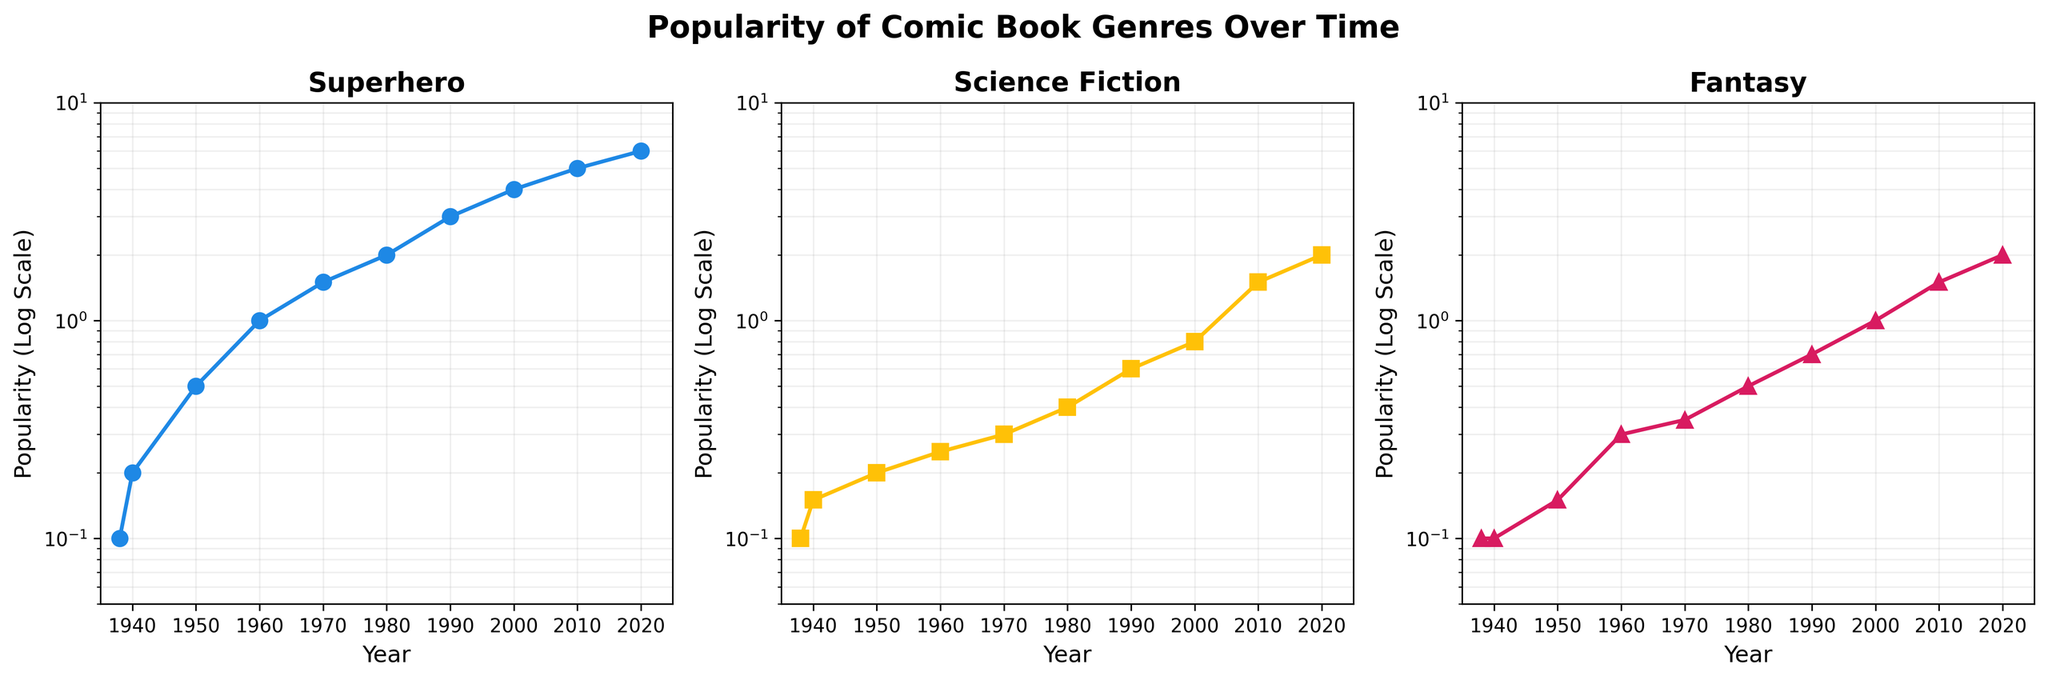How many unique years are represented in each subplot? There are ten unique data points in each subplot, as each genre (Superhero, Science Fiction, Fantasy) has popularity values displayed from 1938 to 2020.
Answer: 10 Which subplot shows the greatest increase in popularity from 1938 to 2020? To determine the greatest increase, we compare the change in popularity values from 1938 to 2020 for each genre. Superhero increased from 0.1 to 6, Science Fiction from 0.1 to 2, and Fantasy from 0.1 to 2. Therefore, the Superhero subplot shows the greatest increase.
Answer: Superhero By what factor did the popularity of Science Fiction change from 1970 to 1990? The popularity of Science Fiction in 1970 was 0.3 and in 1990 was 0.6. The factor change is calculated as 0.6 / 0.3 = 2.
Answer: 2 Between which years did Fantasy experience the most rapid growth? The most rapid growth can be observed between 1980 and 1990, where the popularity of Fantasy increased from 0.5 to 0.7, nearly doubling. By comparing the changes between other decade intervals, this period shows the steepest increase.
Answer: 1980 to 1990 What is the median popularity value for the Superhero genre? The median of the Superhero genre values in log scale can be found by ordering the values: 0.1, 0.2, 0.5, 1, 1.5, 2, 3, 4, 5, 6 and choosing the middle value(s). For 10 data points, the median is the average of the 5th and 6th values: (1.5 + 2) / 2 = 1.75.
Answer: 1.75 In what year did all three genres intersect in popularity? By examining the subplots, it is evident that around the years 2010 to 2020, all three genres have converged to similar popularity values. The closest intersection is around 2010 with all genres showing very similar scales, approximately 1.5.
Answer: 2010 Which genre showed the smallest variability in its popularity over the entire period? To determine variability, observe the range and dispersion in each subplot. Science Fiction shows the smallest range (0.1 to 2) compared to Superhero (0.1 to 6) and Fantasy (0.1 to 2), indicating the least variability.
Answer: Science Fiction Identify the decade where Fantasy outpaced Science Fiction in popularity, if any. By examining the graph, Fantasy began to consistently outpace Science Fiction starting around the 1990s and has maintained higher popularity up to 2020.
Answer: 1990s Is there any decade where the popularity of Superhero genre remained almost constant? By observing the Superhero subplot, it appears that between the periods of 1960 to 1970, the popularity values remain relatively constant, with only a minor increase from 1.0 to 1.5.
Answer: 1960 to 1970 